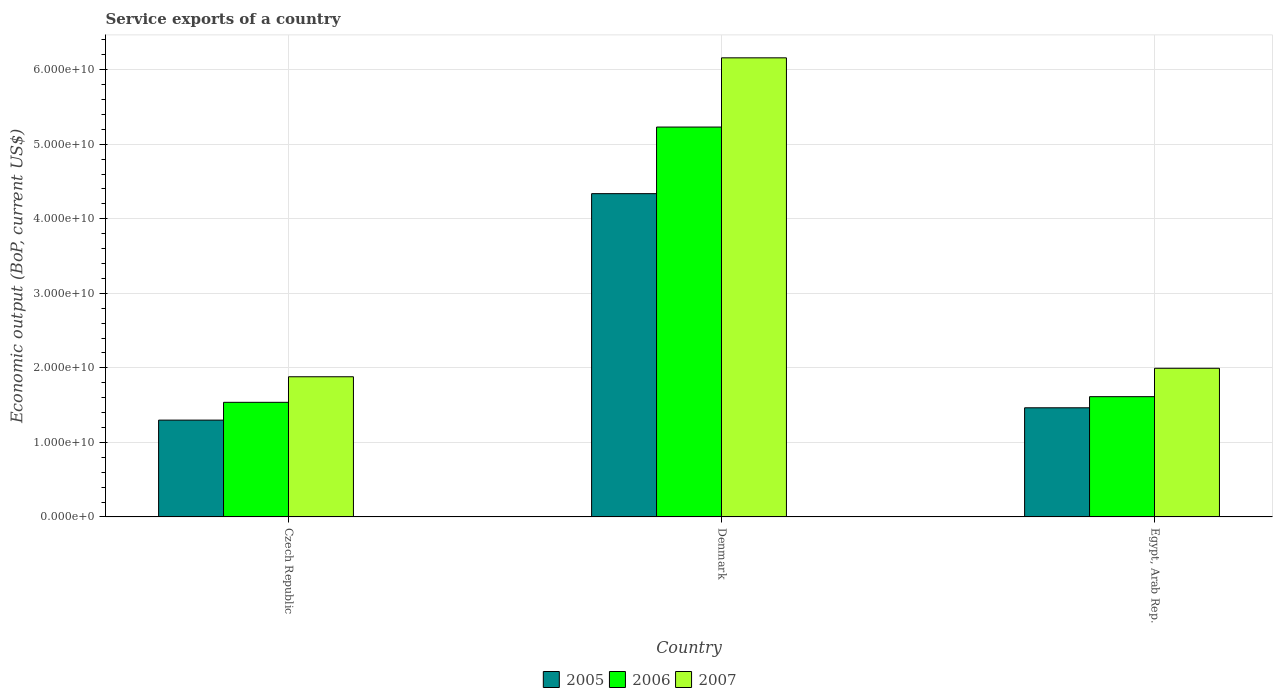How many groups of bars are there?
Offer a very short reply. 3. Are the number of bars per tick equal to the number of legend labels?
Offer a terse response. Yes. Are the number of bars on each tick of the X-axis equal?
Provide a succinct answer. Yes. What is the label of the 3rd group of bars from the left?
Provide a succinct answer. Egypt, Arab Rep. What is the service exports in 2005 in Czech Republic?
Offer a very short reply. 1.30e+1. Across all countries, what is the maximum service exports in 2005?
Keep it short and to the point. 4.34e+1. Across all countries, what is the minimum service exports in 2005?
Make the answer very short. 1.30e+1. In which country was the service exports in 2006 maximum?
Provide a succinct answer. Denmark. In which country was the service exports in 2007 minimum?
Your response must be concise. Czech Republic. What is the total service exports in 2007 in the graph?
Ensure brevity in your answer.  1.00e+11. What is the difference between the service exports in 2005 in Czech Republic and that in Denmark?
Provide a succinct answer. -3.04e+1. What is the difference between the service exports in 2006 in Czech Republic and the service exports in 2005 in Denmark?
Offer a very short reply. -2.80e+1. What is the average service exports in 2007 per country?
Offer a very short reply. 3.34e+1. What is the difference between the service exports of/in 2006 and service exports of/in 2007 in Czech Republic?
Offer a very short reply. -3.43e+09. In how many countries, is the service exports in 2007 greater than 12000000000 US$?
Keep it short and to the point. 3. What is the ratio of the service exports in 2007 in Denmark to that in Egypt, Arab Rep.?
Ensure brevity in your answer.  3.09. Is the difference between the service exports in 2006 in Czech Republic and Denmark greater than the difference between the service exports in 2007 in Czech Republic and Denmark?
Offer a very short reply. Yes. What is the difference between the highest and the second highest service exports in 2006?
Your answer should be compact. 7.59e+08. What is the difference between the highest and the lowest service exports in 2005?
Offer a very short reply. 3.04e+1. What does the 2nd bar from the left in Czech Republic represents?
Ensure brevity in your answer.  2006. How many bars are there?
Ensure brevity in your answer.  9. What is the difference between two consecutive major ticks on the Y-axis?
Make the answer very short. 1.00e+1. Are the values on the major ticks of Y-axis written in scientific E-notation?
Ensure brevity in your answer.  Yes. Does the graph contain any zero values?
Provide a succinct answer. No. How many legend labels are there?
Provide a succinct answer. 3. How are the legend labels stacked?
Provide a short and direct response. Horizontal. What is the title of the graph?
Your response must be concise. Service exports of a country. Does "1998" appear as one of the legend labels in the graph?
Provide a short and direct response. No. What is the label or title of the X-axis?
Your response must be concise. Country. What is the label or title of the Y-axis?
Your answer should be very brief. Economic output (BoP, current US$). What is the Economic output (BoP, current US$) in 2005 in Czech Republic?
Offer a terse response. 1.30e+1. What is the Economic output (BoP, current US$) of 2006 in Czech Republic?
Make the answer very short. 1.54e+1. What is the Economic output (BoP, current US$) in 2007 in Czech Republic?
Make the answer very short. 1.88e+1. What is the Economic output (BoP, current US$) of 2005 in Denmark?
Offer a terse response. 4.34e+1. What is the Economic output (BoP, current US$) of 2006 in Denmark?
Your answer should be very brief. 5.23e+1. What is the Economic output (BoP, current US$) of 2007 in Denmark?
Provide a succinct answer. 6.16e+1. What is the Economic output (BoP, current US$) of 2005 in Egypt, Arab Rep.?
Provide a succinct answer. 1.46e+1. What is the Economic output (BoP, current US$) of 2006 in Egypt, Arab Rep.?
Your response must be concise. 1.61e+1. What is the Economic output (BoP, current US$) of 2007 in Egypt, Arab Rep.?
Provide a short and direct response. 1.99e+1. Across all countries, what is the maximum Economic output (BoP, current US$) in 2005?
Your answer should be compact. 4.34e+1. Across all countries, what is the maximum Economic output (BoP, current US$) in 2006?
Provide a succinct answer. 5.23e+1. Across all countries, what is the maximum Economic output (BoP, current US$) in 2007?
Keep it short and to the point. 6.16e+1. Across all countries, what is the minimum Economic output (BoP, current US$) in 2005?
Ensure brevity in your answer.  1.30e+1. Across all countries, what is the minimum Economic output (BoP, current US$) in 2006?
Your answer should be very brief. 1.54e+1. Across all countries, what is the minimum Economic output (BoP, current US$) of 2007?
Keep it short and to the point. 1.88e+1. What is the total Economic output (BoP, current US$) of 2005 in the graph?
Provide a short and direct response. 7.10e+1. What is the total Economic output (BoP, current US$) in 2006 in the graph?
Provide a short and direct response. 8.38e+1. What is the total Economic output (BoP, current US$) of 2007 in the graph?
Offer a very short reply. 1.00e+11. What is the difference between the Economic output (BoP, current US$) of 2005 in Czech Republic and that in Denmark?
Ensure brevity in your answer.  -3.04e+1. What is the difference between the Economic output (BoP, current US$) in 2006 in Czech Republic and that in Denmark?
Make the answer very short. -3.69e+1. What is the difference between the Economic output (BoP, current US$) of 2007 in Czech Republic and that in Denmark?
Ensure brevity in your answer.  -4.28e+1. What is the difference between the Economic output (BoP, current US$) of 2005 in Czech Republic and that in Egypt, Arab Rep.?
Make the answer very short. -1.65e+09. What is the difference between the Economic output (BoP, current US$) of 2006 in Czech Republic and that in Egypt, Arab Rep.?
Provide a succinct answer. -7.59e+08. What is the difference between the Economic output (BoP, current US$) of 2007 in Czech Republic and that in Egypt, Arab Rep.?
Your answer should be compact. -1.14e+09. What is the difference between the Economic output (BoP, current US$) in 2005 in Denmark and that in Egypt, Arab Rep.?
Make the answer very short. 2.87e+1. What is the difference between the Economic output (BoP, current US$) of 2006 in Denmark and that in Egypt, Arab Rep.?
Your answer should be very brief. 3.62e+1. What is the difference between the Economic output (BoP, current US$) of 2007 in Denmark and that in Egypt, Arab Rep.?
Offer a terse response. 4.17e+1. What is the difference between the Economic output (BoP, current US$) in 2005 in Czech Republic and the Economic output (BoP, current US$) in 2006 in Denmark?
Offer a very short reply. -3.93e+1. What is the difference between the Economic output (BoP, current US$) in 2005 in Czech Republic and the Economic output (BoP, current US$) in 2007 in Denmark?
Your answer should be very brief. -4.86e+1. What is the difference between the Economic output (BoP, current US$) in 2006 in Czech Republic and the Economic output (BoP, current US$) in 2007 in Denmark?
Your answer should be compact. -4.62e+1. What is the difference between the Economic output (BoP, current US$) in 2005 in Czech Republic and the Economic output (BoP, current US$) in 2006 in Egypt, Arab Rep.?
Give a very brief answer. -3.14e+09. What is the difference between the Economic output (BoP, current US$) of 2005 in Czech Republic and the Economic output (BoP, current US$) of 2007 in Egypt, Arab Rep.?
Provide a short and direct response. -6.95e+09. What is the difference between the Economic output (BoP, current US$) of 2006 in Czech Republic and the Economic output (BoP, current US$) of 2007 in Egypt, Arab Rep.?
Provide a short and direct response. -4.57e+09. What is the difference between the Economic output (BoP, current US$) in 2005 in Denmark and the Economic output (BoP, current US$) in 2006 in Egypt, Arab Rep.?
Make the answer very short. 2.72e+1. What is the difference between the Economic output (BoP, current US$) in 2005 in Denmark and the Economic output (BoP, current US$) in 2007 in Egypt, Arab Rep.?
Make the answer very short. 2.34e+1. What is the difference between the Economic output (BoP, current US$) of 2006 in Denmark and the Economic output (BoP, current US$) of 2007 in Egypt, Arab Rep.?
Your response must be concise. 3.24e+1. What is the average Economic output (BoP, current US$) in 2005 per country?
Give a very brief answer. 2.37e+1. What is the average Economic output (BoP, current US$) of 2006 per country?
Offer a very short reply. 2.79e+1. What is the average Economic output (BoP, current US$) of 2007 per country?
Provide a succinct answer. 3.34e+1. What is the difference between the Economic output (BoP, current US$) of 2005 and Economic output (BoP, current US$) of 2006 in Czech Republic?
Provide a succinct answer. -2.39e+09. What is the difference between the Economic output (BoP, current US$) in 2005 and Economic output (BoP, current US$) in 2007 in Czech Republic?
Keep it short and to the point. -5.82e+09. What is the difference between the Economic output (BoP, current US$) in 2006 and Economic output (BoP, current US$) in 2007 in Czech Republic?
Keep it short and to the point. -3.43e+09. What is the difference between the Economic output (BoP, current US$) of 2005 and Economic output (BoP, current US$) of 2006 in Denmark?
Make the answer very short. -8.94e+09. What is the difference between the Economic output (BoP, current US$) in 2005 and Economic output (BoP, current US$) in 2007 in Denmark?
Keep it short and to the point. -1.82e+1. What is the difference between the Economic output (BoP, current US$) of 2006 and Economic output (BoP, current US$) of 2007 in Denmark?
Offer a terse response. -9.29e+09. What is the difference between the Economic output (BoP, current US$) in 2005 and Economic output (BoP, current US$) in 2006 in Egypt, Arab Rep.?
Your answer should be compact. -1.49e+09. What is the difference between the Economic output (BoP, current US$) in 2005 and Economic output (BoP, current US$) in 2007 in Egypt, Arab Rep.?
Make the answer very short. -5.30e+09. What is the difference between the Economic output (BoP, current US$) of 2006 and Economic output (BoP, current US$) of 2007 in Egypt, Arab Rep.?
Ensure brevity in your answer.  -3.81e+09. What is the ratio of the Economic output (BoP, current US$) in 2005 in Czech Republic to that in Denmark?
Your answer should be very brief. 0.3. What is the ratio of the Economic output (BoP, current US$) in 2006 in Czech Republic to that in Denmark?
Keep it short and to the point. 0.29. What is the ratio of the Economic output (BoP, current US$) in 2007 in Czech Republic to that in Denmark?
Keep it short and to the point. 0.31. What is the ratio of the Economic output (BoP, current US$) in 2005 in Czech Republic to that in Egypt, Arab Rep.?
Your answer should be compact. 0.89. What is the ratio of the Economic output (BoP, current US$) in 2006 in Czech Republic to that in Egypt, Arab Rep.?
Ensure brevity in your answer.  0.95. What is the ratio of the Economic output (BoP, current US$) of 2007 in Czech Republic to that in Egypt, Arab Rep.?
Provide a short and direct response. 0.94. What is the ratio of the Economic output (BoP, current US$) of 2005 in Denmark to that in Egypt, Arab Rep.?
Offer a terse response. 2.96. What is the ratio of the Economic output (BoP, current US$) in 2006 in Denmark to that in Egypt, Arab Rep.?
Keep it short and to the point. 3.24. What is the ratio of the Economic output (BoP, current US$) in 2007 in Denmark to that in Egypt, Arab Rep.?
Make the answer very short. 3.09. What is the difference between the highest and the second highest Economic output (BoP, current US$) in 2005?
Your answer should be very brief. 2.87e+1. What is the difference between the highest and the second highest Economic output (BoP, current US$) of 2006?
Your answer should be very brief. 3.62e+1. What is the difference between the highest and the second highest Economic output (BoP, current US$) of 2007?
Your answer should be compact. 4.17e+1. What is the difference between the highest and the lowest Economic output (BoP, current US$) of 2005?
Your answer should be very brief. 3.04e+1. What is the difference between the highest and the lowest Economic output (BoP, current US$) of 2006?
Provide a succinct answer. 3.69e+1. What is the difference between the highest and the lowest Economic output (BoP, current US$) in 2007?
Offer a terse response. 4.28e+1. 